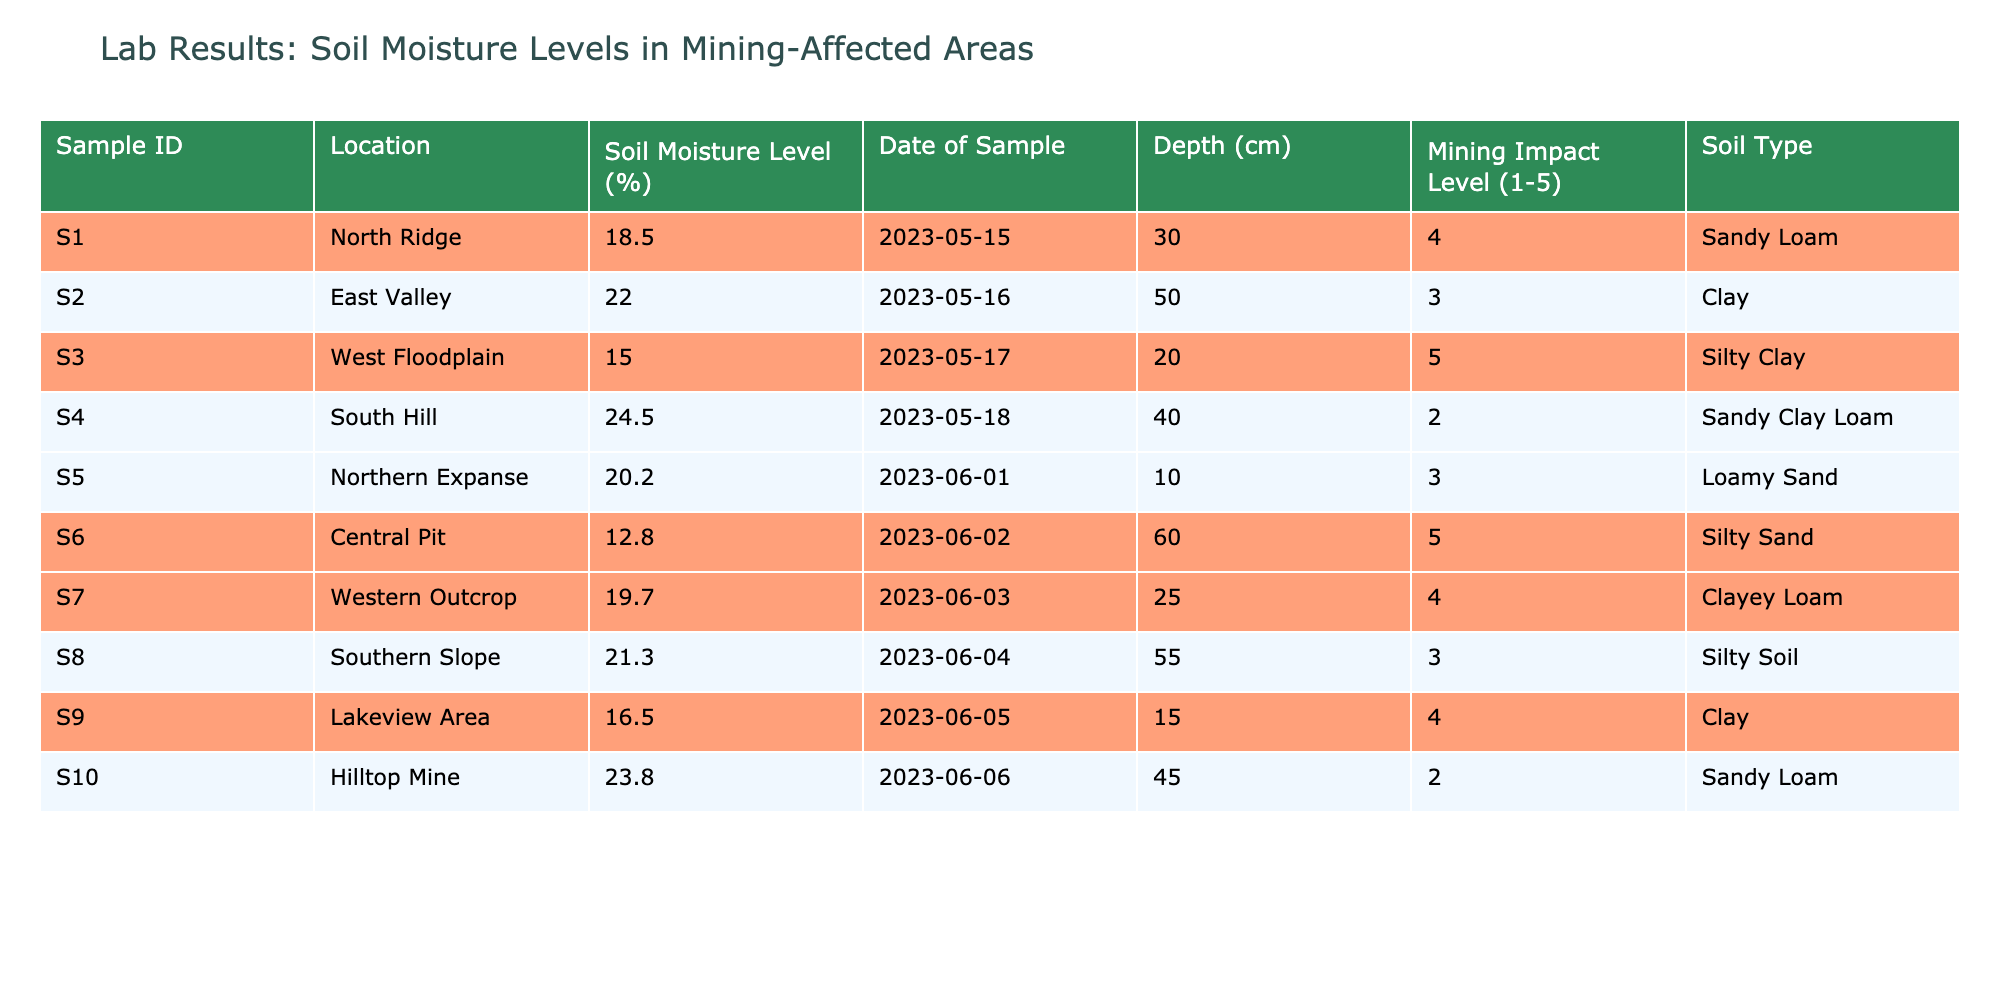What is the soil moisture level at the West Floodplain? The table lists the soil moisture levels for various locations. For the West Floodplain (Sample ID S3), the soil moisture level is directly mentioned in the table as 15.0%.
Answer: 15.0% How many samples have a mining impact level of 4 or higher? By examining the Mining Impact Level column, I can see that four samples (S3, S6, S1, and S7) have a Mining Impact Level of 4 or higher.
Answer: 4 What is the average soil moisture level in the Southern Slope and Northern Expanse? The soil moisture levels in the Southern Slope (S8) and Northern Expanse (S5) are 21.3% and 20.2%, respectively. The average is calculated as (21.3 + 20.2) / 2 = 20.75%.
Answer: 20.75% Is there any sample with a soil moisture level above 24%? A quick review of the Soil Moisture Level column reveals that the highest moisture level is 24.5%, from the South Hill (Sample ID S4), confirming that at least one sample does exceed 24%.
Answer: Yes What is the difference in soil moisture levels between the Lakeview Area and the Central Pit? The soil moisture level in the Lakeview Area (S9) is 16.5%, while in the Central Pit (S6) it is 12.8%. The difference is calculated as 16.5 - 12.8 = 3.7%.
Answer: 3.7% What is the soil type of the sample obtained from the Hilltop Mine? Referring to the Soil Type column for Sample ID S10 (Hilltop Mine), it is classified as Sandy Loam.
Answer: Sandy Loam How many samples were taken from a depth of more than 50 cm? Looking at the Depth column, only one sample (S2) is taken from a depth greater than 50 cm, specifically at 50 cm.
Answer: 1 Which location has the highest soil moisture level? The highest soil moisture level recorded in the table is 24.5% from South Hill (Sample ID S4).
Answer: South Hill What is the range of soil moisture levels recorded in these samples? By identifying the highest (24.5% from S4) and lowest (12.8% from S6) moisture levels, the range is calculated as 24.5 - 12.8 = 11.7%.
Answer: 11.7% Do any of the samples indicate a clay soil type? The Soil Type column shows that there are two samples where the soil type is clay, specifically in the East Valley (S2) and Lakeview Area (S9).
Answer: Yes 